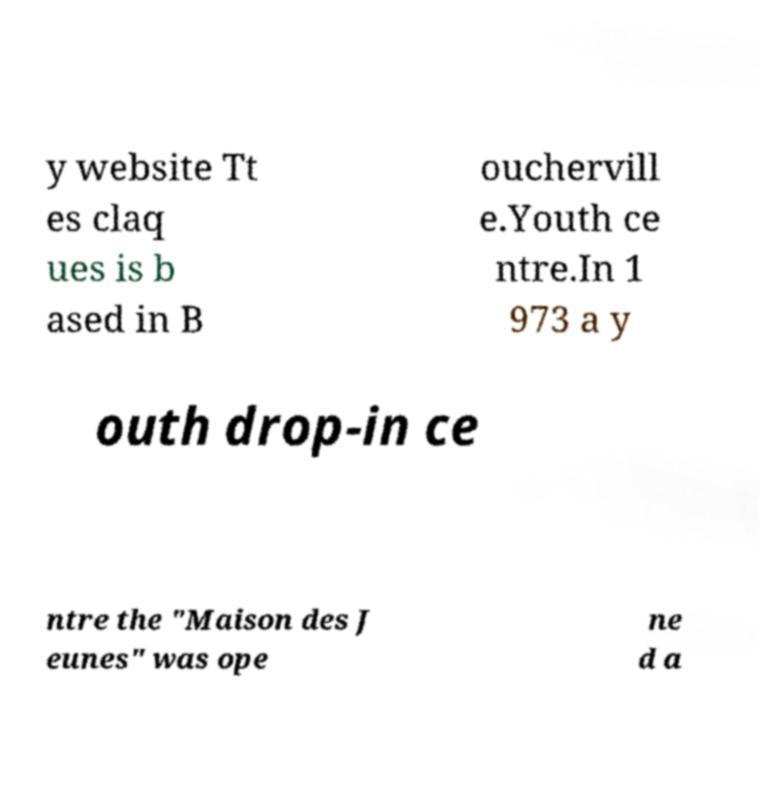What messages or text are displayed in this image? I need them in a readable, typed format. y website Tt es claq ues is b ased in B ouchervill e.Youth ce ntre.In 1 973 a y outh drop-in ce ntre the "Maison des J eunes" was ope ne d a 